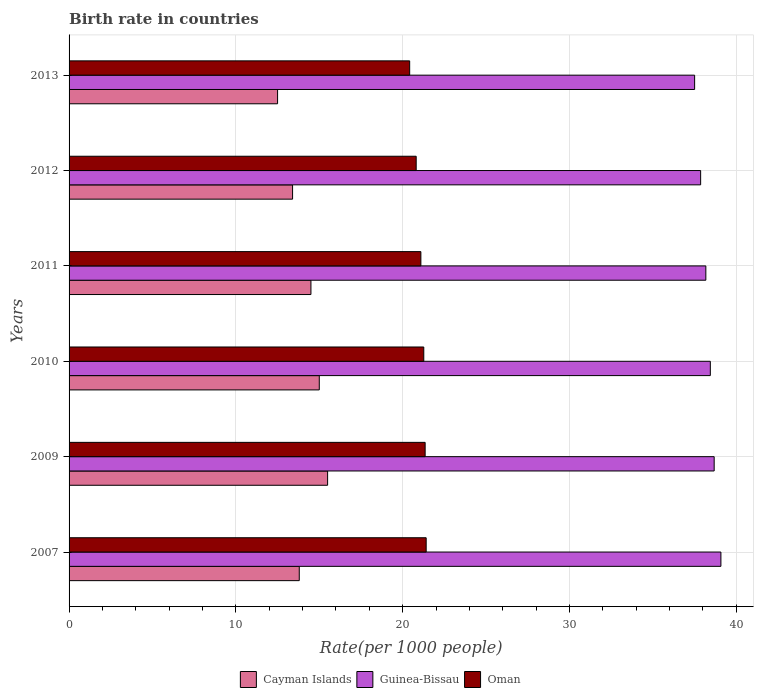How many different coloured bars are there?
Provide a short and direct response. 3. How many groups of bars are there?
Offer a very short reply. 6. Are the number of bars per tick equal to the number of legend labels?
Offer a very short reply. Yes. Are the number of bars on each tick of the Y-axis equal?
Keep it short and to the point. Yes. How many bars are there on the 5th tick from the top?
Give a very brief answer. 3. How many bars are there on the 2nd tick from the bottom?
Ensure brevity in your answer.  3. In how many cases, is the number of bars for a given year not equal to the number of legend labels?
Offer a terse response. 0. What is the birth rate in Guinea-Bissau in 2007?
Offer a very short reply. 39.08. Across all years, what is the minimum birth rate in Oman?
Offer a terse response. 20.42. In which year was the birth rate in Guinea-Bissau maximum?
Give a very brief answer. 2007. What is the total birth rate in Oman in the graph?
Keep it short and to the point. 126.34. What is the difference between the birth rate in Guinea-Bissau in 2011 and that in 2013?
Your answer should be compact. 0.67. What is the difference between the birth rate in Guinea-Bissau in 2013 and the birth rate in Cayman Islands in 2007?
Offer a very short reply. 23.7. What is the average birth rate in Guinea-Bissau per year?
Provide a succinct answer. 38.29. In the year 2012, what is the difference between the birth rate in Cayman Islands and birth rate in Guinea-Bissau?
Ensure brevity in your answer.  -24.46. In how many years, is the birth rate in Oman greater than 4 ?
Your answer should be very brief. 6. What is the ratio of the birth rate in Oman in 2011 to that in 2013?
Your answer should be compact. 1.03. Is the birth rate in Oman in 2011 less than that in 2013?
Your answer should be very brief. No. What is the difference between the highest and the second highest birth rate in Guinea-Bissau?
Offer a terse response. 0.4. What is the difference between the highest and the lowest birth rate in Oman?
Offer a terse response. 0.99. What does the 1st bar from the top in 2012 represents?
Your answer should be compact. Oman. What does the 1st bar from the bottom in 2007 represents?
Your answer should be compact. Cayman Islands. What is the difference between two consecutive major ticks on the X-axis?
Provide a short and direct response. 10. Does the graph contain grids?
Your answer should be very brief. Yes. Where does the legend appear in the graph?
Provide a short and direct response. Bottom center. What is the title of the graph?
Your response must be concise. Birth rate in countries. Does "Jamaica" appear as one of the legend labels in the graph?
Your response must be concise. No. What is the label or title of the X-axis?
Make the answer very short. Rate(per 1000 people). What is the label or title of the Y-axis?
Your answer should be very brief. Years. What is the Rate(per 1000 people) in Guinea-Bissau in 2007?
Provide a short and direct response. 39.08. What is the Rate(per 1000 people) of Oman in 2007?
Keep it short and to the point. 21.41. What is the Rate(per 1000 people) in Guinea-Bissau in 2009?
Ensure brevity in your answer.  38.67. What is the Rate(per 1000 people) of Oman in 2009?
Make the answer very short. 21.35. What is the Rate(per 1000 people) of Cayman Islands in 2010?
Offer a very short reply. 15. What is the Rate(per 1000 people) of Guinea-Bissau in 2010?
Provide a succinct answer. 38.44. What is the Rate(per 1000 people) of Oman in 2010?
Your answer should be very brief. 21.27. What is the Rate(per 1000 people) of Cayman Islands in 2011?
Ensure brevity in your answer.  14.5. What is the Rate(per 1000 people) of Guinea-Bissau in 2011?
Offer a terse response. 38.17. What is the Rate(per 1000 people) in Oman in 2011?
Ensure brevity in your answer.  21.09. What is the Rate(per 1000 people) in Guinea-Bissau in 2012?
Ensure brevity in your answer.  37.86. What is the Rate(per 1000 people) of Oman in 2012?
Make the answer very short. 20.81. What is the Rate(per 1000 people) in Cayman Islands in 2013?
Offer a terse response. 12.5. What is the Rate(per 1000 people) of Guinea-Bissau in 2013?
Your response must be concise. 37.5. What is the Rate(per 1000 people) in Oman in 2013?
Your answer should be compact. 20.42. Across all years, what is the maximum Rate(per 1000 people) in Cayman Islands?
Provide a succinct answer. 15.5. Across all years, what is the maximum Rate(per 1000 people) of Guinea-Bissau?
Your answer should be very brief. 39.08. Across all years, what is the maximum Rate(per 1000 people) of Oman?
Ensure brevity in your answer.  21.41. Across all years, what is the minimum Rate(per 1000 people) in Cayman Islands?
Provide a short and direct response. 12.5. Across all years, what is the minimum Rate(per 1000 people) of Guinea-Bissau?
Provide a succinct answer. 37.5. Across all years, what is the minimum Rate(per 1000 people) in Oman?
Keep it short and to the point. 20.42. What is the total Rate(per 1000 people) in Cayman Islands in the graph?
Your response must be concise. 84.7. What is the total Rate(per 1000 people) of Guinea-Bissau in the graph?
Your response must be concise. 229.74. What is the total Rate(per 1000 people) in Oman in the graph?
Give a very brief answer. 126.34. What is the difference between the Rate(per 1000 people) of Cayman Islands in 2007 and that in 2009?
Offer a very short reply. -1.7. What is the difference between the Rate(per 1000 people) of Guinea-Bissau in 2007 and that in 2009?
Keep it short and to the point. 0.4. What is the difference between the Rate(per 1000 people) in Oman in 2007 and that in 2009?
Give a very brief answer. 0.06. What is the difference between the Rate(per 1000 people) in Guinea-Bissau in 2007 and that in 2010?
Your answer should be very brief. 0.63. What is the difference between the Rate(per 1000 people) in Oman in 2007 and that in 2010?
Provide a short and direct response. 0.14. What is the difference between the Rate(per 1000 people) in Guinea-Bissau in 2007 and that in 2011?
Provide a succinct answer. 0.9. What is the difference between the Rate(per 1000 people) of Oman in 2007 and that in 2011?
Provide a short and direct response. 0.32. What is the difference between the Rate(per 1000 people) of Cayman Islands in 2007 and that in 2012?
Offer a very short reply. 0.4. What is the difference between the Rate(per 1000 people) of Guinea-Bissau in 2007 and that in 2012?
Make the answer very short. 1.22. What is the difference between the Rate(per 1000 people) of Oman in 2007 and that in 2012?
Your answer should be compact. 0.6. What is the difference between the Rate(per 1000 people) in Guinea-Bissau in 2007 and that in 2013?
Make the answer very short. 1.57. What is the difference between the Rate(per 1000 people) of Oman in 2007 and that in 2013?
Give a very brief answer. 0.99. What is the difference between the Rate(per 1000 people) in Cayman Islands in 2009 and that in 2010?
Give a very brief answer. 0.5. What is the difference between the Rate(per 1000 people) in Guinea-Bissau in 2009 and that in 2010?
Your response must be concise. 0.23. What is the difference between the Rate(per 1000 people) in Oman in 2009 and that in 2010?
Provide a succinct answer. 0.08. What is the difference between the Rate(per 1000 people) in Cayman Islands in 2009 and that in 2011?
Offer a very short reply. 1. What is the difference between the Rate(per 1000 people) of Guinea-Bissau in 2009 and that in 2011?
Ensure brevity in your answer.  0.5. What is the difference between the Rate(per 1000 people) in Oman in 2009 and that in 2011?
Make the answer very short. 0.26. What is the difference between the Rate(per 1000 people) of Cayman Islands in 2009 and that in 2012?
Offer a terse response. 2.1. What is the difference between the Rate(per 1000 people) in Guinea-Bissau in 2009 and that in 2012?
Keep it short and to the point. 0.81. What is the difference between the Rate(per 1000 people) of Oman in 2009 and that in 2012?
Your answer should be very brief. 0.54. What is the difference between the Rate(per 1000 people) in Cayman Islands in 2009 and that in 2013?
Your response must be concise. 3. What is the difference between the Rate(per 1000 people) of Guinea-Bissau in 2009 and that in 2013?
Ensure brevity in your answer.  1.17. What is the difference between the Rate(per 1000 people) of Oman in 2009 and that in 2013?
Your answer should be very brief. 0.93. What is the difference between the Rate(per 1000 people) in Guinea-Bissau in 2010 and that in 2011?
Your answer should be very brief. 0.27. What is the difference between the Rate(per 1000 people) in Oman in 2010 and that in 2011?
Provide a succinct answer. 0.17. What is the difference between the Rate(per 1000 people) in Guinea-Bissau in 2010 and that in 2012?
Give a very brief answer. 0.58. What is the difference between the Rate(per 1000 people) in Oman in 2010 and that in 2012?
Your answer should be compact. 0.46. What is the difference between the Rate(per 1000 people) in Cayman Islands in 2010 and that in 2013?
Ensure brevity in your answer.  2.5. What is the difference between the Rate(per 1000 people) in Guinea-Bissau in 2010 and that in 2013?
Your answer should be compact. 0.94. What is the difference between the Rate(per 1000 people) in Oman in 2010 and that in 2013?
Your answer should be very brief. 0.85. What is the difference between the Rate(per 1000 people) in Guinea-Bissau in 2011 and that in 2012?
Offer a terse response. 0.31. What is the difference between the Rate(per 1000 people) of Oman in 2011 and that in 2012?
Ensure brevity in your answer.  0.28. What is the difference between the Rate(per 1000 people) in Guinea-Bissau in 2011 and that in 2013?
Provide a short and direct response. 0.67. What is the difference between the Rate(per 1000 people) in Oman in 2011 and that in 2013?
Make the answer very short. 0.67. What is the difference between the Rate(per 1000 people) in Guinea-Bissau in 2012 and that in 2013?
Make the answer very short. 0.36. What is the difference between the Rate(per 1000 people) in Oman in 2012 and that in 2013?
Your answer should be compact. 0.39. What is the difference between the Rate(per 1000 people) in Cayman Islands in 2007 and the Rate(per 1000 people) in Guinea-Bissau in 2009?
Give a very brief answer. -24.88. What is the difference between the Rate(per 1000 people) of Cayman Islands in 2007 and the Rate(per 1000 people) of Oman in 2009?
Offer a very short reply. -7.55. What is the difference between the Rate(per 1000 people) of Guinea-Bissau in 2007 and the Rate(per 1000 people) of Oman in 2009?
Make the answer very short. 17.73. What is the difference between the Rate(per 1000 people) in Cayman Islands in 2007 and the Rate(per 1000 people) in Guinea-Bissau in 2010?
Ensure brevity in your answer.  -24.64. What is the difference between the Rate(per 1000 people) in Cayman Islands in 2007 and the Rate(per 1000 people) in Oman in 2010?
Your response must be concise. -7.46. What is the difference between the Rate(per 1000 people) in Guinea-Bissau in 2007 and the Rate(per 1000 people) in Oman in 2010?
Your answer should be compact. 17.81. What is the difference between the Rate(per 1000 people) in Cayman Islands in 2007 and the Rate(per 1000 people) in Guinea-Bissau in 2011?
Provide a succinct answer. -24.38. What is the difference between the Rate(per 1000 people) of Cayman Islands in 2007 and the Rate(per 1000 people) of Oman in 2011?
Keep it short and to the point. -7.29. What is the difference between the Rate(per 1000 people) in Guinea-Bissau in 2007 and the Rate(per 1000 people) in Oman in 2011?
Give a very brief answer. 17.99. What is the difference between the Rate(per 1000 people) of Cayman Islands in 2007 and the Rate(per 1000 people) of Guinea-Bissau in 2012?
Offer a very short reply. -24.06. What is the difference between the Rate(per 1000 people) in Cayman Islands in 2007 and the Rate(per 1000 people) in Oman in 2012?
Give a very brief answer. -7.01. What is the difference between the Rate(per 1000 people) of Guinea-Bissau in 2007 and the Rate(per 1000 people) of Oman in 2012?
Provide a short and direct response. 18.27. What is the difference between the Rate(per 1000 people) of Cayman Islands in 2007 and the Rate(per 1000 people) of Guinea-Bissau in 2013?
Keep it short and to the point. -23.7. What is the difference between the Rate(per 1000 people) of Cayman Islands in 2007 and the Rate(per 1000 people) of Oman in 2013?
Give a very brief answer. -6.62. What is the difference between the Rate(per 1000 people) of Guinea-Bissau in 2007 and the Rate(per 1000 people) of Oman in 2013?
Give a very brief answer. 18.66. What is the difference between the Rate(per 1000 people) of Cayman Islands in 2009 and the Rate(per 1000 people) of Guinea-Bissau in 2010?
Your response must be concise. -22.94. What is the difference between the Rate(per 1000 people) in Cayman Islands in 2009 and the Rate(per 1000 people) in Oman in 2010?
Your answer should be very brief. -5.76. What is the difference between the Rate(per 1000 people) of Guinea-Bissau in 2009 and the Rate(per 1000 people) of Oman in 2010?
Your answer should be compact. 17.41. What is the difference between the Rate(per 1000 people) in Cayman Islands in 2009 and the Rate(per 1000 people) in Guinea-Bissau in 2011?
Your answer should be compact. -22.68. What is the difference between the Rate(per 1000 people) of Cayman Islands in 2009 and the Rate(per 1000 people) of Oman in 2011?
Keep it short and to the point. -5.59. What is the difference between the Rate(per 1000 people) in Guinea-Bissau in 2009 and the Rate(per 1000 people) in Oman in 2011?
Your answer should be very brief. 17.58. What is the difference between the Rate(per 1000 people) in Cayman Islands in 2009 and the Rate(per 1000 people) in Guinea-Bissau in 2012?
Your answer should be very brief. -22.36. What is the difference between the Rate(per 1000 people) of Cayman Islands in 2009 and the Rate(per 1000 people) of Oman in 2012?
Provide a short and direct response. -5.31. What is the difference between the Rate(per 1000 people) in Guinea-Bissau in 2009 and the Rate(per 1000 people) in Oman in 2012?
Offer a terse response. 17.86. What is the difference between the Rate(per 1000 people) of Cayman Islands in 2009 and the Rate(per 1000 people) of Guinea-Bissau in 2013?
Your answer should be compact. -22. What is the difference between the Rate(per 1000 people) of Cayman Islands in 2009 and the Rate(per 1000 people) of Oman in 2013?
Your answer should be very brief. -4.92. What is the difference between the Rate(per 1000 people) in Guinea-Bissau in 2009 and the Rate(per 1000 people) in Oman in 2013?
Give a very brief answer. 18.26. What is the difference between the Rate(per 1000 people) of Cayman Islands in 2010 and the Rate(per 1000 people) of Guinea-Bissau in 2011?
Give a very brief answer. -23.18. What is the difference between the Rate(per 1000 people) in Cayman Islands in 2010 and the Rate(per 1000 people) in Oman in 2011?
Provide a succinct answer. -6.09. What is the difference between the Rate(per 1000 people) in Guinea-Bissau in 2010 and the Rate(per 1000 people) in Oman in 2011?
Give a very brief answer. 17.35. What is the difference between the Rate(per 1000 people) in Cayman Islands in 2010 and the Rate(per 1000 people) in Guinea-Bissau in 2012?
Offer a very short reply. -22.86. What is the difference between the Rate(per 1000 people) of Cayman Islands in 2010 and the Rate(per 1000 people) of Oman in 2012?
Offer a terse response. -5.81. What is the difference between the Rate(per 1000 people) of Guinea-Bissau in 2010 and the Rate(per 1000 people) of Oman in 2012?
Provide a short and direct response. 17.63. What is the difference between the Rate(per 1000 people) in Cayman Islands in 2010 and the Rate(per 1000 people) in Guinea-Bissau in 2013?
Offer a very short reply. -22.5. What is the difference between the Rate(per 1000 people) in Cayman Islands in 2010 and the Rate(per 1000 people) in Oman in 2013?
Provide a succinct answer. -5.42. What is the difference between the Rate(per 1000 people) in Guinea-Bissau in 2010 and the Rate(per 1000 people) in Oman in 2013?
Provide a succinct answer. 18.02. What is the difference between the Rate(per 1000 people) in Cayman Islands in 2011 and the Rate(per 1000 people) in Guinea-Bissau in 2012?
Keep it short and to the point. -23.36. What is the difference between the Rate(per 1000 people) in Cayman Islands in 2011 and the Rate(per 1000 people) in Oman in 2012?
Make the answer very short. -6.31. What is the difference between the Rate(per 1000 people) of Guinea-Bissau in 2011 and the Rate(per 1000 people) of Oman in 2012?
Make the answer very short. 17.36. What is the difference between the Rate(per 1000 people) in Cayman Islands in 2011 and the Rate(per 1000 people) in Guinea-Bissau in 2013?
Provide a short and direct response. -23. What is the difference between the Rate(per 1000 people) of Cayman Islands in 2011 and the Rate(per 1000 people) of Oman in 2013?
Provide a short and direct response. -5.92. What is the difference between the Rate(per 1000 people) of Guinea-Bissau in 2011 and the Rate(per 1000 people) of Oman in 2013?
Make the answer very short. 17.76. What is the difference between the Rate(per 1000 people) of Cayman Islands in 2012 and the Rate(per 1000 people) of Guinea-Bissau in 2013?
Offer a very short reply. -24.1. What is the difference between the Rate(per 1000 people) in Cayman Islands in 2012 and the Rate(per 1000 people) in Oman in 2013?
Offer a very short reply. -7.02. What is the difference between the Rate(per 1000 people) of Guinea-Bissau in 2012 and the Rate(per 1000 people) of Oman in 2013?
Ensure brevity in your answer.  17.44. What is the average Rate(per 1000 people) of Cayman Islands per year?
Give a very brief answer. 14.12. What is the average Rate(per 1000 people) of Guinea-Bissau per year?
Your answer should be compact. 38.29. What is the average Rate(per 1000 people) of Oman per year?
Offer a very short reply. 21.06. In the year 2007, what is the difference between the Rate(per 1000 people) of Cayman Islands and Rate(per 1000 people) of Guinea-Bissau?
Make the answer very short. -25.28. In the year 2007, what is the difference between the Rate(per 1000 people) of Cayman Islands and Rate(per 1000 people) of Oman?
Give a very brief answer. -7.61. In the year 2007, what is the difference between the Rate(per 1000 people) in Guinea-Bissau and Rate(per 1000 people) in Oman?
Make the answer very short. 17.67. In the year 2009, what is the difference between the Rate(per 1000 people) in Cayman Islands and Rate(per 1000 people) in Guinea-Bissau?
Offer a very short reply. -23.18. In the year 2009, what is the difference between the Rate(per 1000 people) of Cayman Islands and Rate(per 1000 people) of Oman?
Provide a succinct answer. -5.85. In the year 2009, what is the difference between the Rate(per 1000 people) of Guinea-Bissau and Rate(per 1000 people) of Oman?
Ensure brevity in your answer.  17.33. In the year 2010, what is the difference between the Rate(per 1000 people) in Cayman Islands and Rate(per 1000 people) in Guinea-Bissau?
Provide a short and direct response. -23.44. In the year 2010, what is the difference between the Rate(per 1000 people) of Cayman Islands and Rate(per 1000 people) of Oman?
Keep it short and to the point. -6.26. In the year 2010, what is the difference between the Rate(per 1000 people) of Guinea-Bissau and Rate(per 1000 people) of Oman?
Provide a succinct answer. 17.18. In the year 2011, what is the difference between the Rate(per 1000 people) in Cayman Islands and Rate(per 1000 people) in Guinea-Bissau?
Provide a succinct answer. -23.68. In the year 2011, what is the difference between the Rate(per 1000 people) of Cayman Islands and Rate(per 1000 people) of Oman?
Your response must be concise. -6.59. In the year 2011, what is the difference between the Rate(per 1000 people) of Guinea-Bissau and Rate(per 1000 people) of Oman?
Offer a very short reply. 17.08. In the year 2012, what is the difference between the Rate(per 1000 people) of Cayman Islands and Rate(per 1000 people) of Guinea-Bissau?
Offer a terse response. -24.46. In the year 2012, what is the difference between the Rate(per 1000 people) in Cayman Islands and Rate(per 1000 people) in Oman?
Give a very brief answer. -7.41. In the year 2012, what is the difference between the Rate(per 1000 people) in Guinea-Bissau and Rate(per 1000 people) in Oman?
Your answer should be compact. 17.05. In the year 2013, what is the difference between the Rate(per 1000 people) of Cayman Islands and Rate(per 1000 people) of Guinea-Bissau?
Ensure brevity in your answer.  -25. In the year 2013, what is the difference between the Rate(per 1000 people) in Cayman Islands and Rate(per 1000 people) in Oman?
Your response must be concise. -7.92. In the year 2013, what is the difference between the Rate(per 1000 people) in Guinea-Bissau and Rate(per 1000 people) in Oman?
Offer a very short reply. 17.08. What is the ratio of the Rate(per 1000 people) of Cayman Islands in 2007 to that in 2009?
Ensure brevity in your answer.  0.89. What is the ratio of the Rate(per 1000 people) of Guinea-Bissau in 2007 to that in 2009?
Keep it short and to the point. 1.01. What is the ratio of the Rate(per 1000 people) of Oman in 2007 to that in 2009?
Your answer should be compact. 1. What is the ratio of the Rate(per 1000 people) in Guinea-Bissau in 2007 to that in 2010?
Offer a very short reply. 1.02. What is the ratio of the Rate(per 1000 people) of Oman in 2007 to that in 2010?
Your response must be concise. 1.01. What is the ratio of the Rate(per 1000 people) of Cayman Islands in 2007 to that in 2011?
Provide a short and direct response. 0.95. What is the ratio of the Rate(per 1000 people) of Guinea-Bissau in 2007 to that in 2011?
Your answer should be very brief. 1.02. What is the ratio of the Rate(per 1000 people) of Oman in 2007 to that in 2011?
Provide a succinct answer. 1.02. What is the ratio of the Rate(per 1000 people) of Cayman Islands in 2007 to that in 2012?
Ensure brevity in your answer.  1.03. What is the ratio of the Rate(per 1000 people) in Guinea-Bissau in 2007 to that in 2012?
Offer a very short reply. 1.03. What is the ratio of the Rate(per 1000 people) in Oman in 2007 to that in 2012?
Your answer should be compact. 1.03. What is the ratio of the Rate(per 1000 people) of Cayman Islands in 2007 to that in 2013?
Offer a terse response. 1.1. What is the ratio of the Rate(per 1000 people) in Guinea-Bissau in 2007 to that in 2013?
Provide a succinct answer. 1.04. What is the ratio of the Rate(per 1000 people) in Oman in 2007 to that in 2013?
Offer a terse response. 1.05. What is the ratio of the Rate(per 1000 people) of Cayman Islands in 2009 to that in 2010?
Provide a short and direct response. 1.03. What is the ratio of the Rate(per 1000 people) of Oman in 2009 to that in 2010?
Keep it short and to the point. 1. What is the ratio of the Rate(per 1000 people) of Cayman Islands in 2009 to that in 2011?
Ensure brevity in your answer.  1.07. What is the ratio of the Rate(per 1000 people) of Guinea-Bissau in 2009 to that in 2011?
Offer a very short reply. 1.01. What is the ratio of the Rate(per 1000 people) of Oman in 2009 to that in 2011?
Ensure brevity in your answer.  1.01. What is the ratio of the Rate(per 1000 people) in Cayman Islands in 2009 to that in 2012?
Offer a terse response. 1.16. What is the ratio of the Rate(per 1000 people) in Guinea-Bissau in 2009 to that in 2012?
Make the answer very short. 1.02. What is the ratio of the Rate(per 1000 people) in Oman in 2009 to that in 2012?
Keep it short and to the point. 1.03. What is the ratio of the Rate(per 1000 people) of Cayman Islands in 2009 to that in 2013?
Your response must be concise. 1.24. What is the ratio of the Rate(per 1000 people) in Guinea-Bissau in 2009 to that in 2013?
Ensure brevity in your answer.  1.03. What is the ratio of the Rate(per 1000 people) in Oman in 2009 to that in 2013?
Provide a short and direct response. 1.05. What is the ratio of the Rate(per 1000 people) in Cayman Islands in 2010 to that in 2011?
Offer a very short reply. 1.03. What is the ratio of the Rate(per 1000 people) in Guinea-Bissau in 2010 to that in 2011?
Keep it short and to the point. 1.01. What is the ratio of the Rate(per 1000 people) of Oman in 2010 to that in 2011?
Offer a very short reply. 1.01. What is the ratio of the Rate(per 1000 people) of Cayman Islands in 2010 to that in 2012?
Your response must be concise. 1.12. What is the ratio of the Rate(per 1000 people) of Guinea-Bissau in 2010 to that in 2012?
Provide a short and direct response. 1.02. What is the ratio of the Rate(per 1000 people) of Oman in 2010 to that in 2012?
Provide a succinct answer. 1.02. What is the ratio of the Rate(per 1000 people) in Cayman Islands in 2010 to that in 2013?
Make the answer very short. 1.2. What is the ratio of the Rate(per 1000 people) of Guinea-Bissau in 2010 to that in 2013?
Your answer should be very brief. 1.03. What is the ratio of the Rate(per 1000 people) of Oman in 2010 to that in 2013?
Make the answer very short. 1.04. What is the ratio of the Rate(per 1000 people) of Cayman Islands in 2011 to that in 2012?
Provide a short and direct response. 1.08. What is the ratio of the Rate(per 1000 people) of Guinea-Bissau in 2011 to that in 2012?
Provide a succinct answer. 1.01. What is the ratio of the Rate(per 1000 people) of Oman in 2011 to that in 2012?
Give a very brief answer. 1.01. What is the ratio of the Rate(per 1000 people) in Cayman Islands in 2011 to that in 2013?
Offer a very short reply. 1.16. What is the ratio of the Rate(per 1000 people) of Guinea-Bissau in 2011 to that in 2013?
Give a very brief answer. 1.02. What is the ratio of the Rate(per 1000 people) of Oman in 2011 to that in 2013?
Provide a short and direct response. 1.03. What is the ratio of the Rate(per 1000 people) of Cayman Islands in 2012 to that in 2013?
Give a very brief answer. 1.07. What is the ratio of the Rate(per 1000 people) of Guinea-Bissau in 2012 to that in 2013?
Your answer should be very brief. 1.01. What is the ratio of the Rate(per 1000 people) in Oman in 2012 to that in 2013?
Make the answer very short. 1.02. What is the difference between the highest and the second highest Rate(per 1000 people) in Cayman Islands?
Ensure brevity in your answer.  0.5. What is the difference between the highest and the second highest Rate(per 1000 people) of Guinea-Bissau?
Your answer should be very brief. 0.4. What is the difference between the highest and the second highest Rate(per 1000 people) of Oman?
Give a very brief answer. 0.06. What is the difference between the highest and the lowest Rate(per 1000 people) of Guinea-Bissau?
Your answer should be very brief. 1.57. What is the difference between the highest and the lowest Rate(per 1000 people) in Oman?
Your answer should be compact. 0.99. 